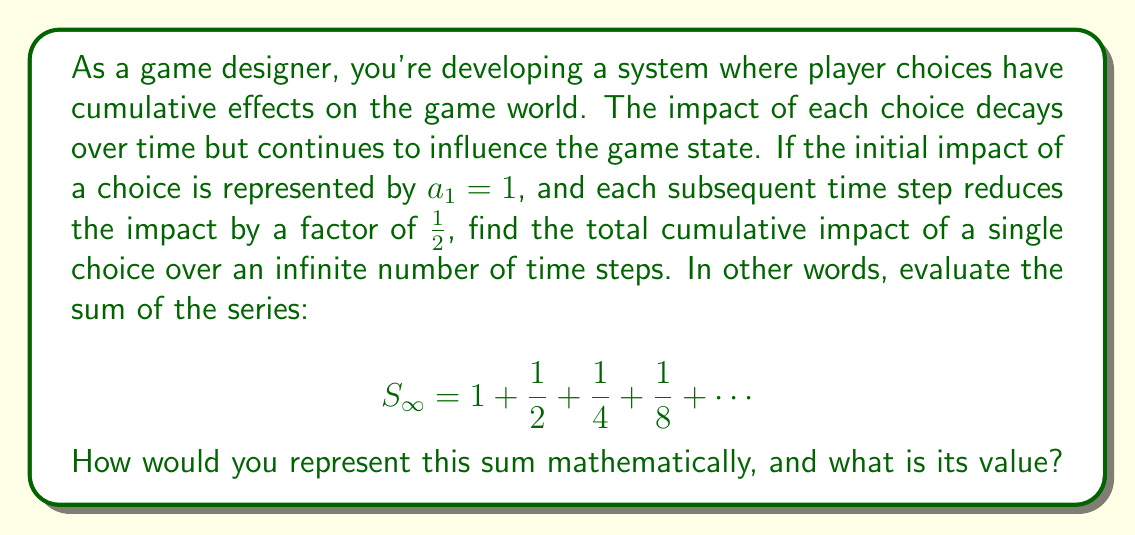Give your solution to this math problem. To solve this problem, we need to recognize that this is a geometric series with an infinite number of terms. Let's approach this step-by-step:

1) First, let's identify the components of our geometric series:
   - The first term, $a = 1$
   - The common ratio, $r = \frac{1}{2}$

2) The general formula for the sum of an infinite geometric series is:

   $$S_{\infty} = \frac{a}{1-r}$$

   where $|r| < 1$ for the series to converge.

3) In our case, $|r| = |\frac{1}{2}| = 0.5 < 1$, so the series does converge.

4) Substituting our values into the formula:

   $$S_{\infty} = \frac{1}{1-\frac{1}{2}} = \frac{1}{\frac{1}{2}} = 2$$

5) Therefore, the sum of the infinite series is 2.

In the context of game design, this means that the total cumulative impact of a single choice, over an infinite number of time steps, is twice the initial impact. This could be interpreted as the choice having a lasting effect on the game world, even as its immediate impact diminishes over time.
Answer: $$S_{\infty} = \frac{a}{1-r} = \frac{1}{1-\frac{1}{2}} = 2$$ 